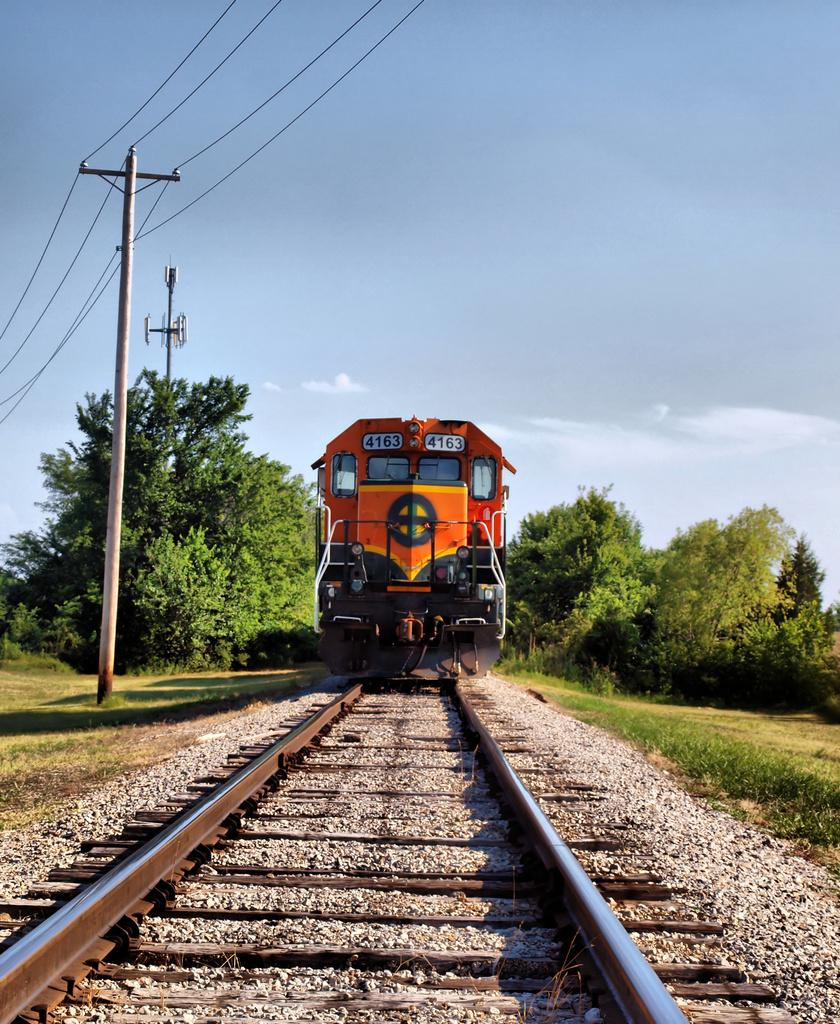What is the main subject of the image? The main subject of the image is a train on the track. What type of vegetation can be seen in the image? There is grass visible in the image. What structures are present in the image? There are poles and trees in the image. What can be seen in the background of the image? The sky is visible in the background of the image. What type of apparel is the tiger wearing in the image? There is no tiger present in the image, and therefore no apparel can be observed. How many planes are flying in the sky in the image? There are no planes visible in the sky in the image. 